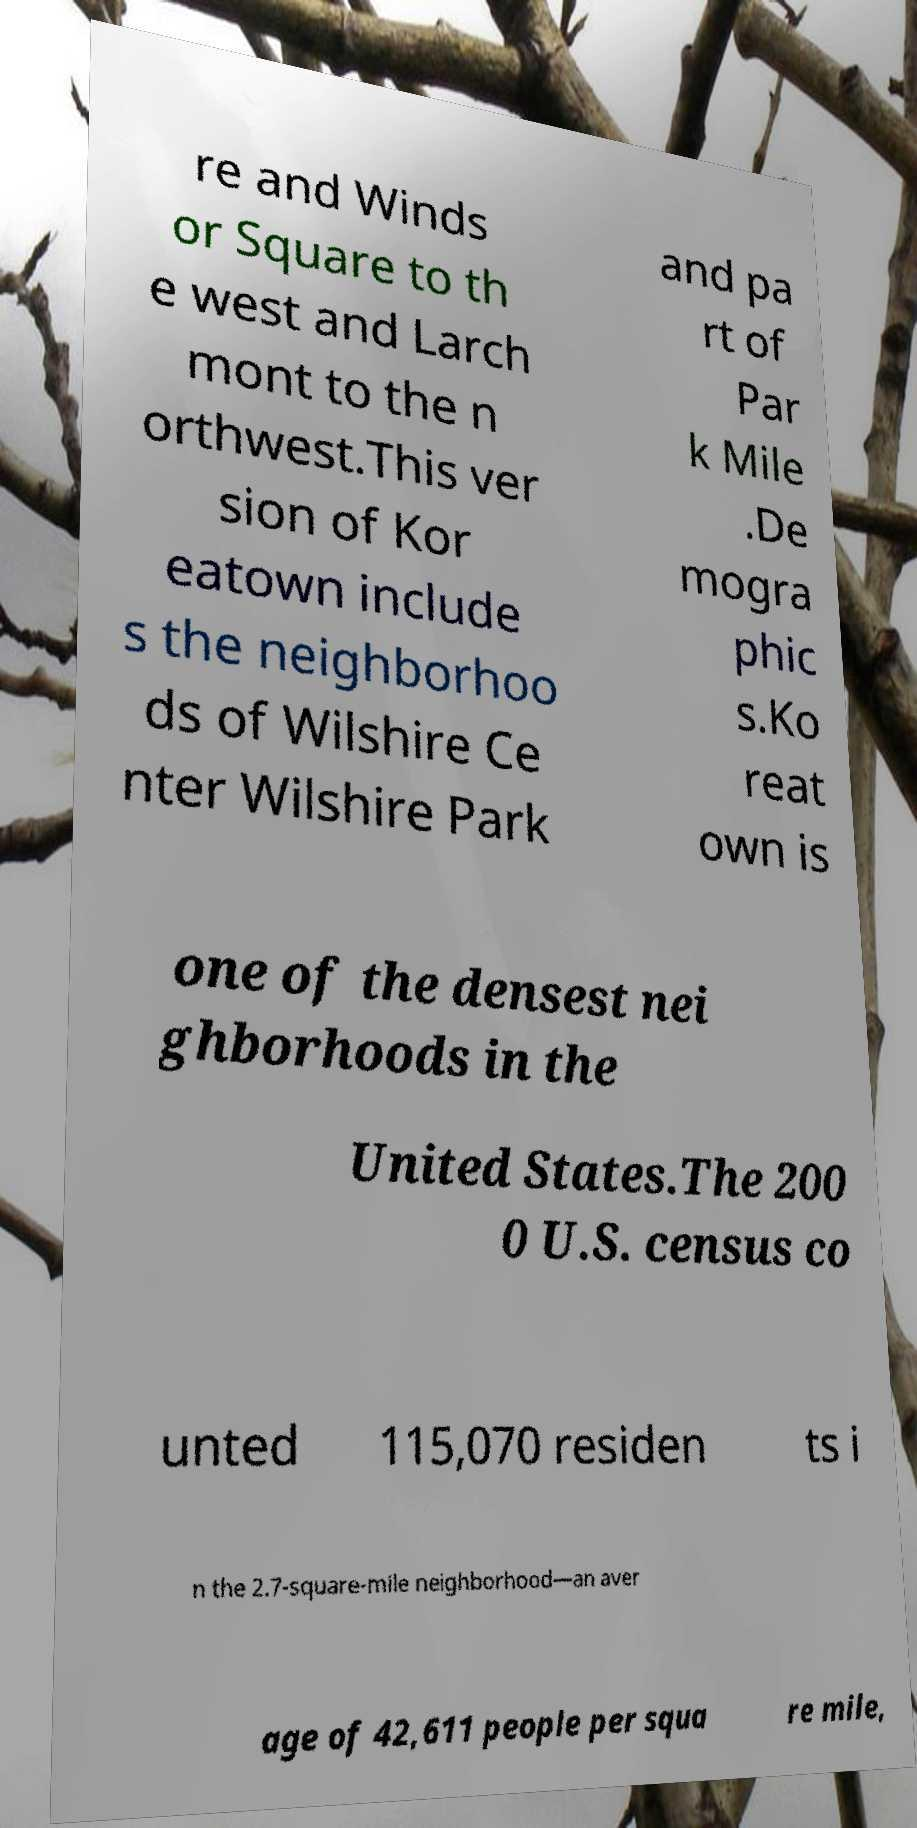I need the written content from this picture converted into text. Can you do that? re and Winds or Square to th e west and Larch mont to the n orthwest.This ver sion of Kor eatown include s the neighborhoo ds of Wilshire Ce nter Wilshire Park and pa rt of Par k Mile .De mogra phic s.Ko reat own is one of the densest nei ghborhoods in the United States.The 200 0 U.S. census co unted 115,070 residen ts i n the 2.7-square-mile neighborhood—an aver age of 42,611 people per squa re mile, 